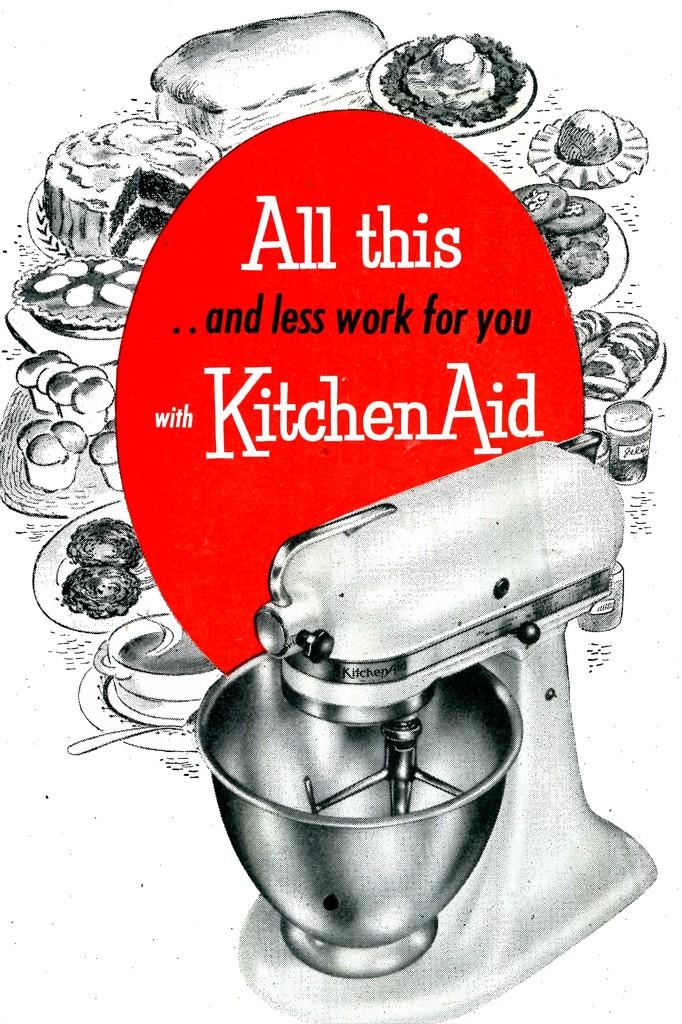What brand is advertised?
Make the answer very short. Kitchenaid. 